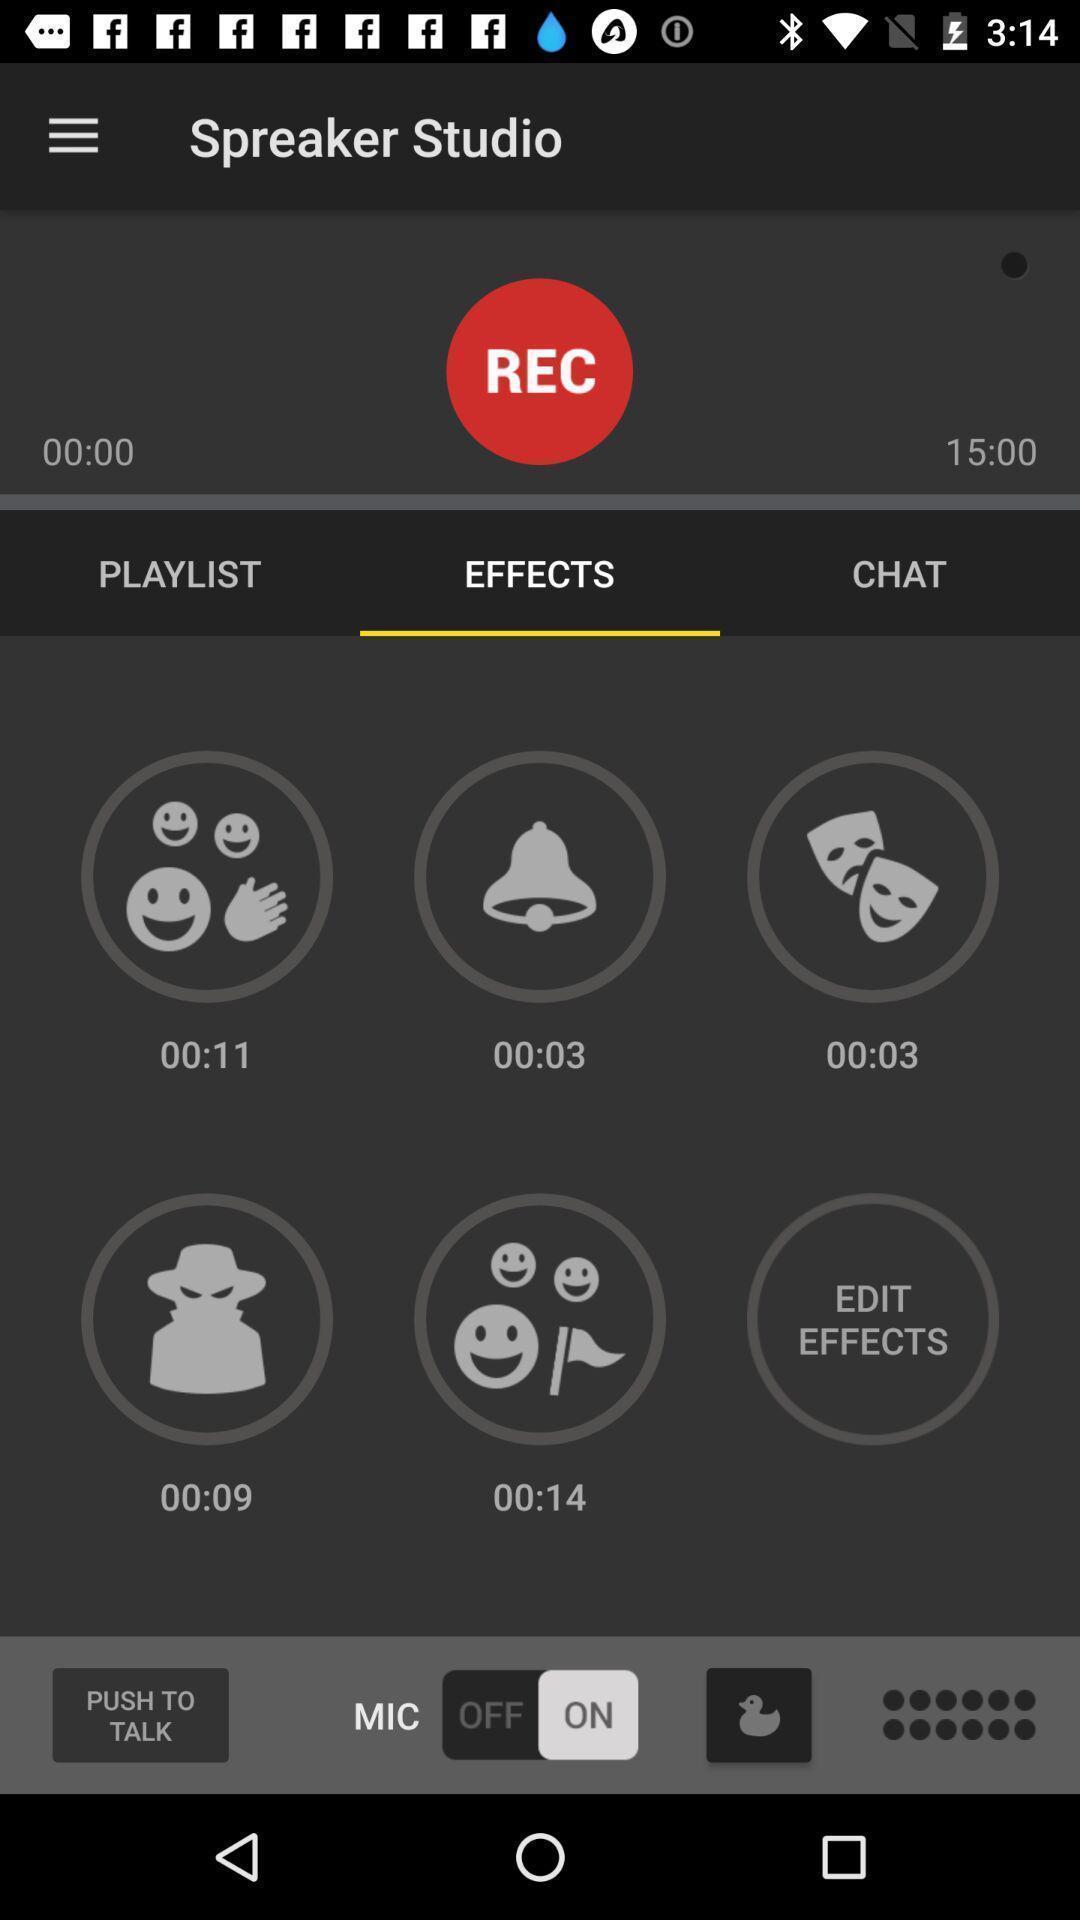Please provide a description for this image. Page displays the effects of the recordings. 